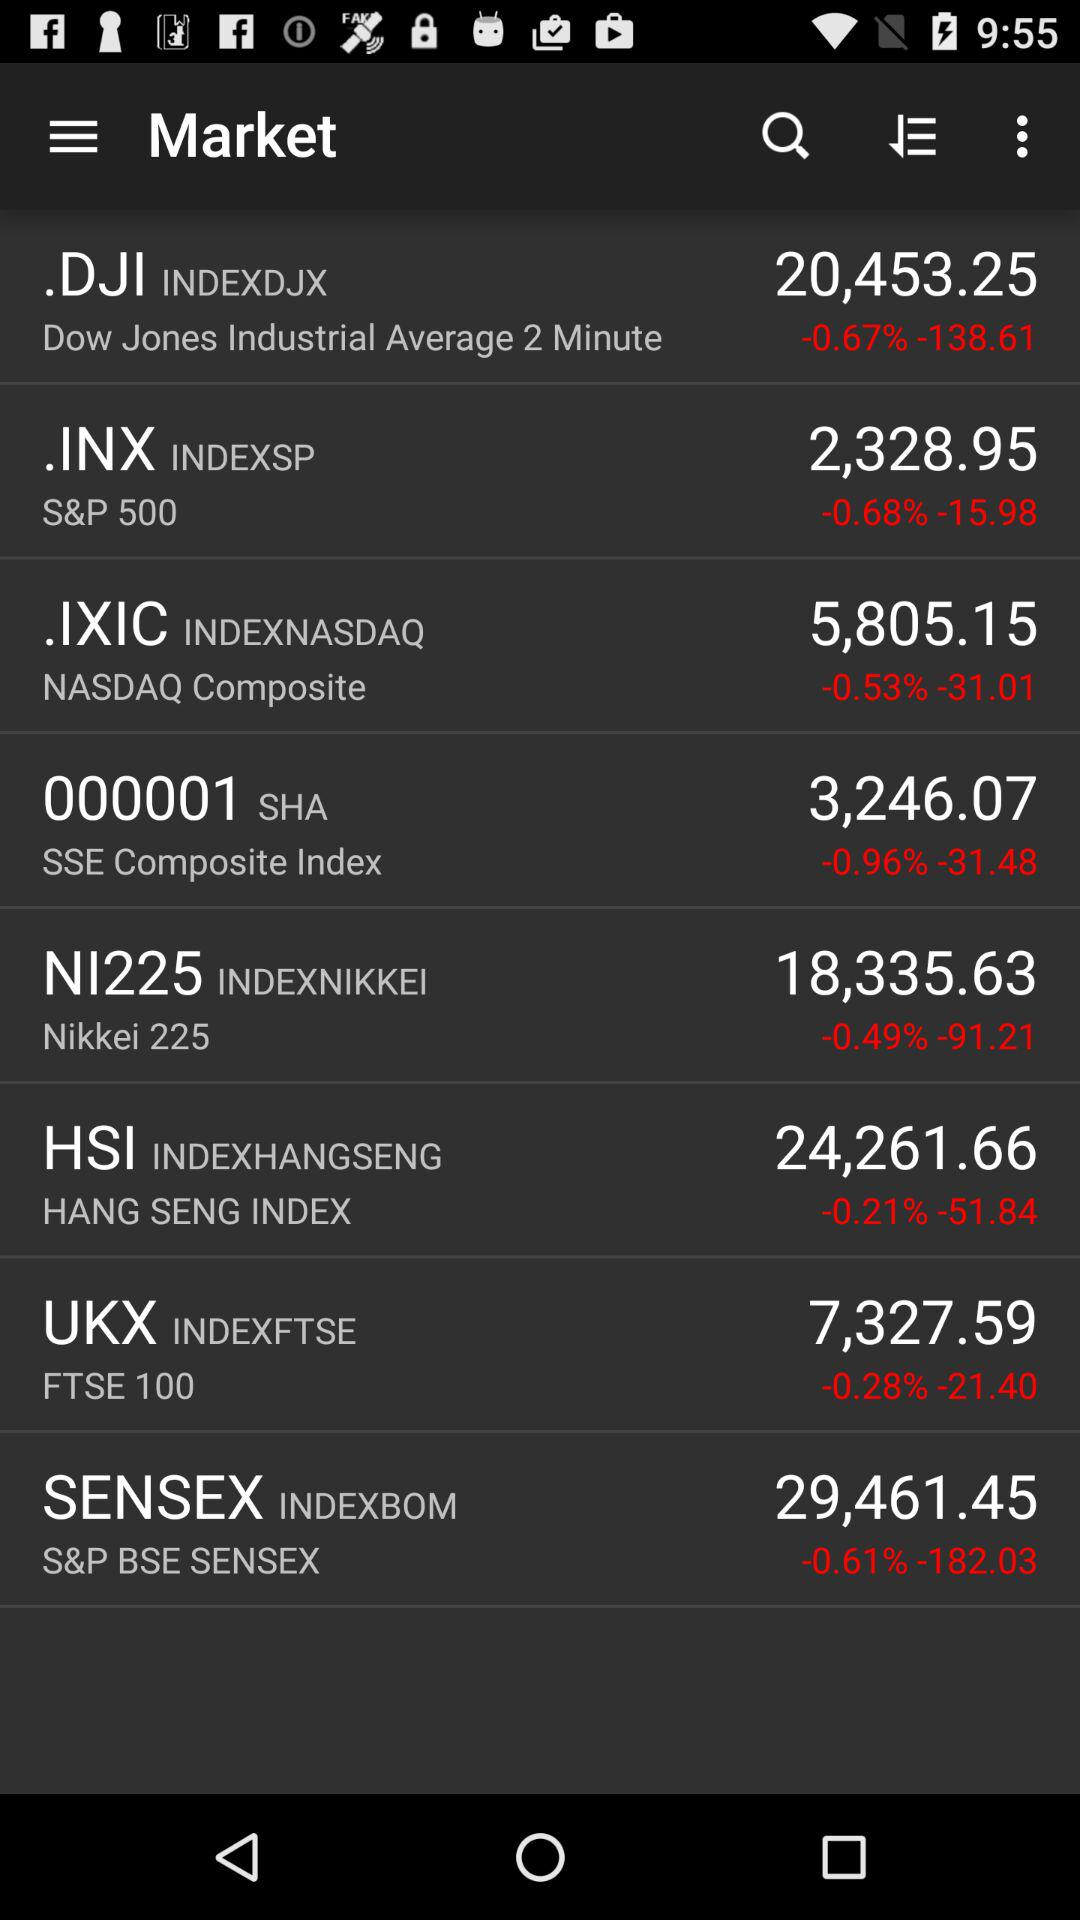What is the industrial average time duration?
When the provided information is insufficient, respond with <no answer>. <no answer> 